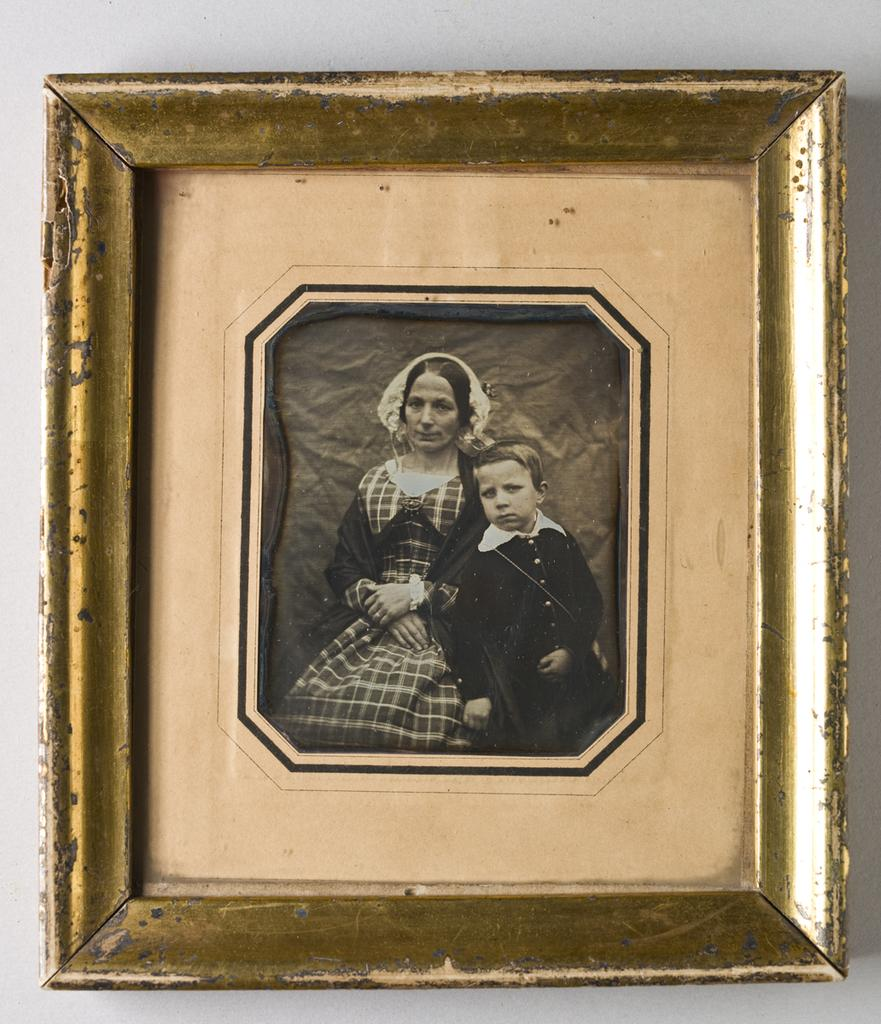What object is present in the image that typically holds a photograph? There is a photo frame in the image. What can be seen inside the photo frame? The photo frame contains a picture of a woman and a child. What is the color scheme of the picture inside the photo frame? The picture is in black and white. How many servants are visible in the image? There are no servants present in the image. What type of curve can be seen in the image? There is no curve visible in the image. 